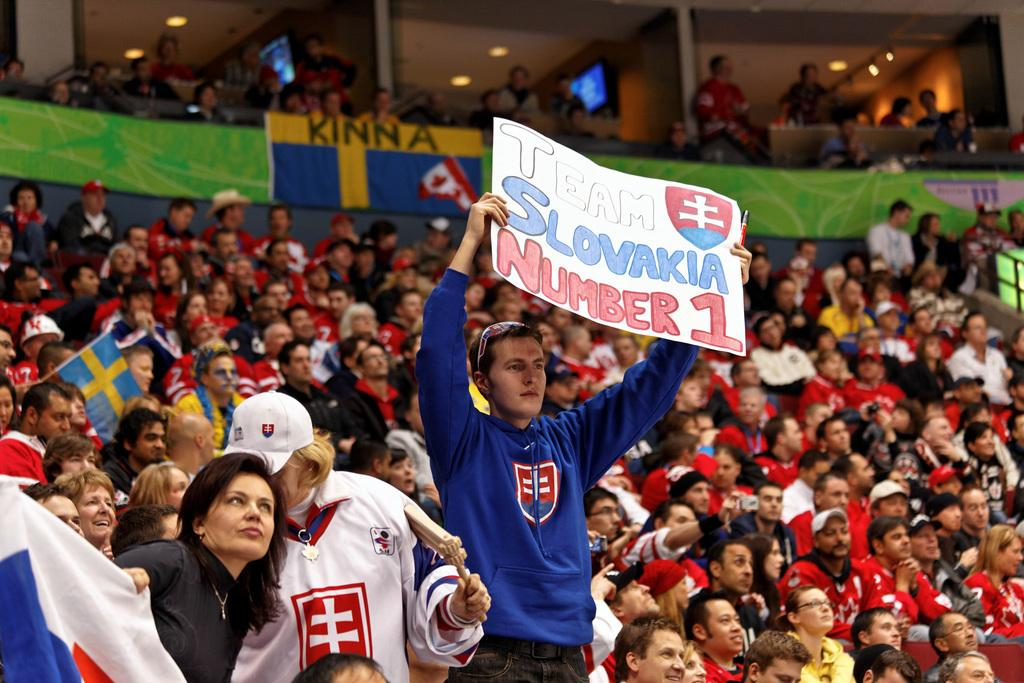What is the person in the image wearing? The person is wearing a blue dress in the image. What is the person doing in the image? The person is standing and holding a sheet of paper. What can be seen on the sheet of paper? The sheet of paper has something written on it. Are there any other people visible in the image? Yes, there are other people behind the person. What type of poison is the person holding in the image? There is no poison present in the image; the person is holding a sheet of paper. What kind of rail is the person leaning on in the image? There is no rail present in the image; the person is standing without any support. 